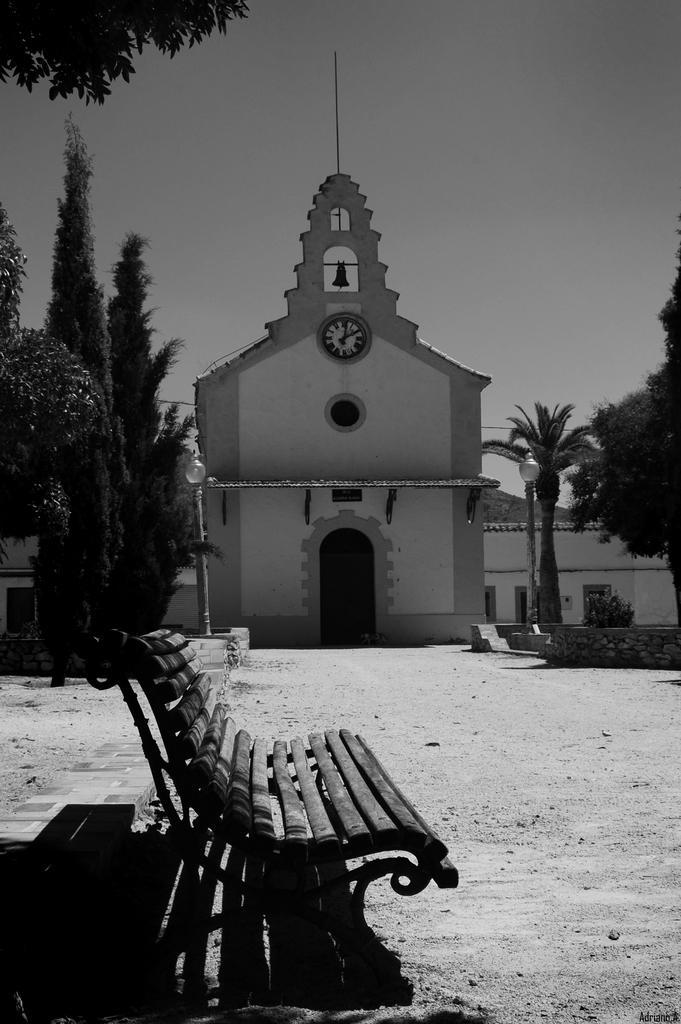In one or two sentences, can you explain what this image depicts? In this picture we can see a bench, in the background we can find few trees, poles, lights and buildings, and it is a black and white photography. 